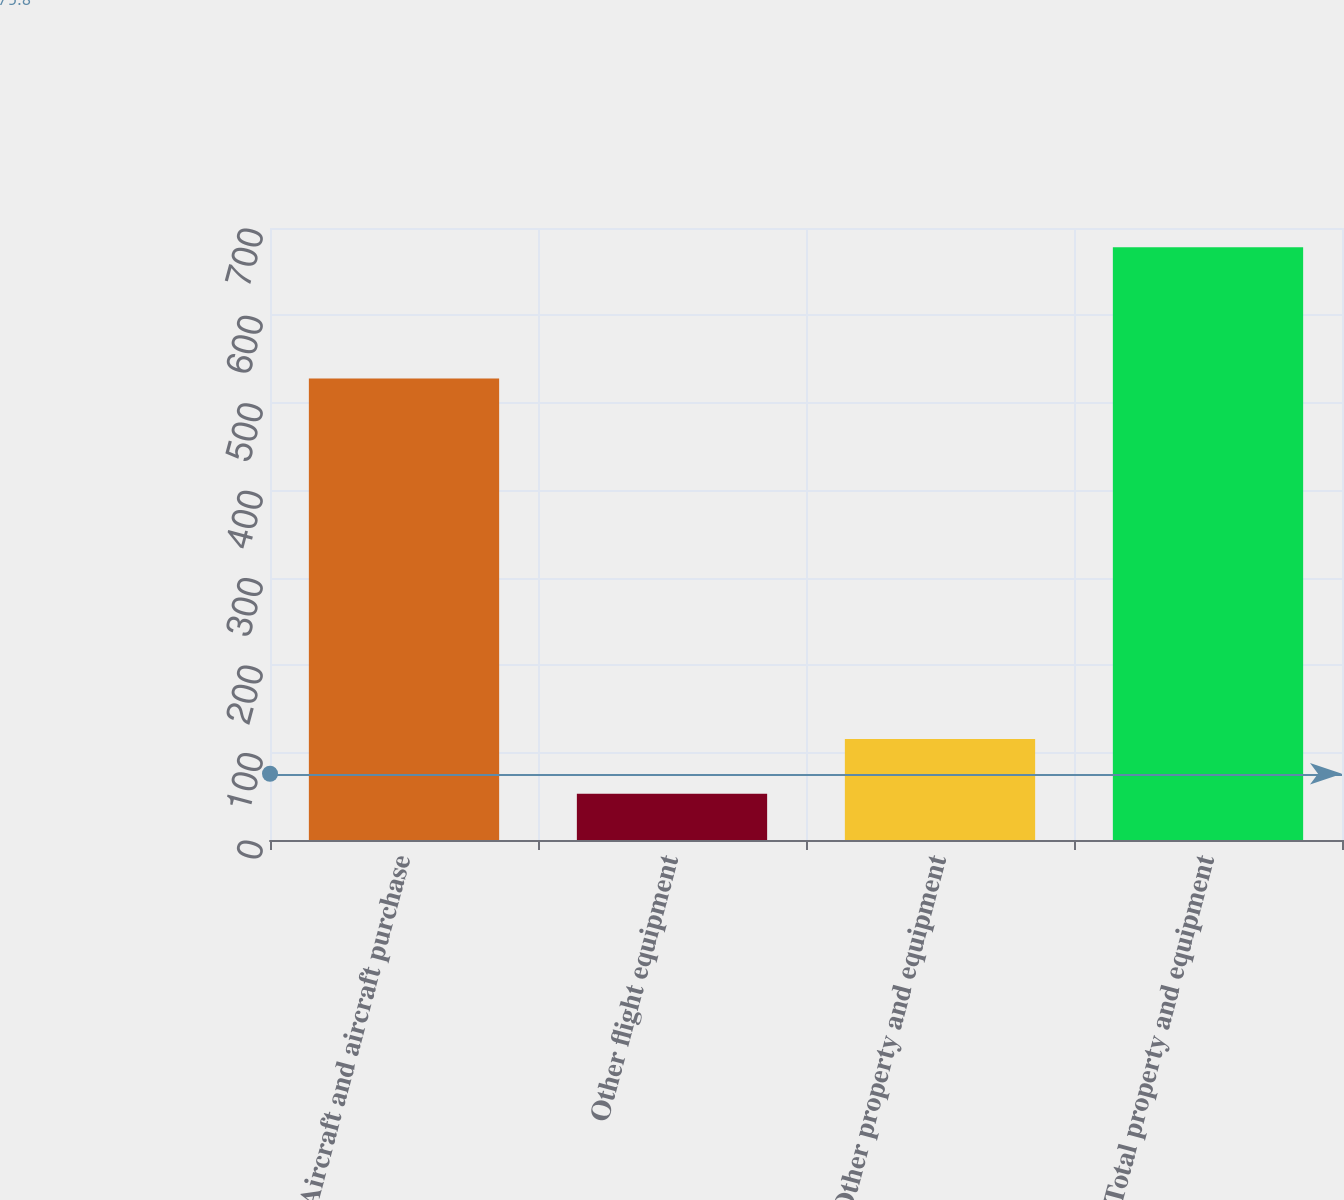<chart> <loc_0><loc_0><loc_500><loc_500><bar_chart><fcel>Aircraft and aircraft purchase<fcel>Other flight equipment<fcel>Other property and equipment<fcel>Total property and equipment<nl><fcel>528<fcel>53<fcel>115.5<fcel>678<nl></chart> 